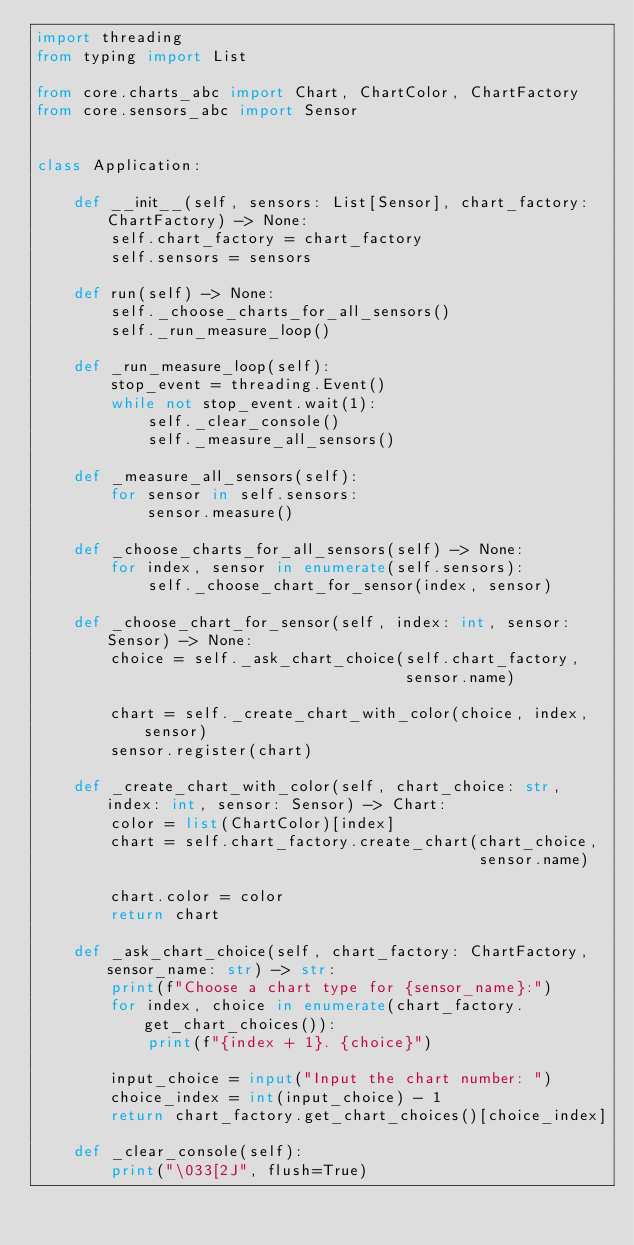<code> <loc_0><loc_0><loc_500><loc_500><_Python_>import threading
from typing import List

from core.charts_abc import Chart, ChartColor, ChartFactory
from core.sensors_abc import Sensor


class Application:

    def __init__(self, sensors: List[Sensor], chart_factory: ChartFactory) -> None:
        self.chart_factory = chart_factory
        self.sensors = sensors

    def run(self) -> None:
        self._choose_charts_for_all_sensors()
        self._run_measure_loop()

    def _run_measure_loop(self):
        stop_event = threading.Event()
        while not stop_event.wait(1):
            self._clear_console()
            self._measure_all_sensors()

    def _measure_all_sensors(self):
        for sensor in self.sensors:
            sensor.measure()

    def _choose_charts_for_all_sensors(self) -> None:
        for index, sensor in enumerate(self.sensors):
            self._choose_chart_for_sensor(index, sensor)

    def _choose_chart_for_sensor(self, index: int, sensor: Sensor) -> None:
        choice = self._ask_chart_choice(self.chart_factory,
                                        sensor.name)

        chart = self._create_chart_with_color(choice, index, sensor)
        sensor.register(chart)

    def _create_chart_with_color(self, chart_choice: str, index: int, sensor: Sensor) -> Chart:
        color = list(ChartColor)[index]
        chart = self.chart_factory.create_chart(chart_choice,
                                                sensor.name)

        chart.color = color
        return chart

    def _ask_chart_choice(self, chart_factory: ChartFactory, sensor_name: str) -> str:
        print(f"Choose a chart type for {sensor_name}:")
        for index, choice in enumerate(chart_factory.get_chart_choices()):
            print(f"{index + 1}. {choice}")

        input_choice = input("Input the chart number: ")
        choice_index = int(input_choice) - 1
        return chart_factory.get_chart_choices()[choice_index]

    def _clear_console(self):
        print("\033[2J", flush=True)
</code> 